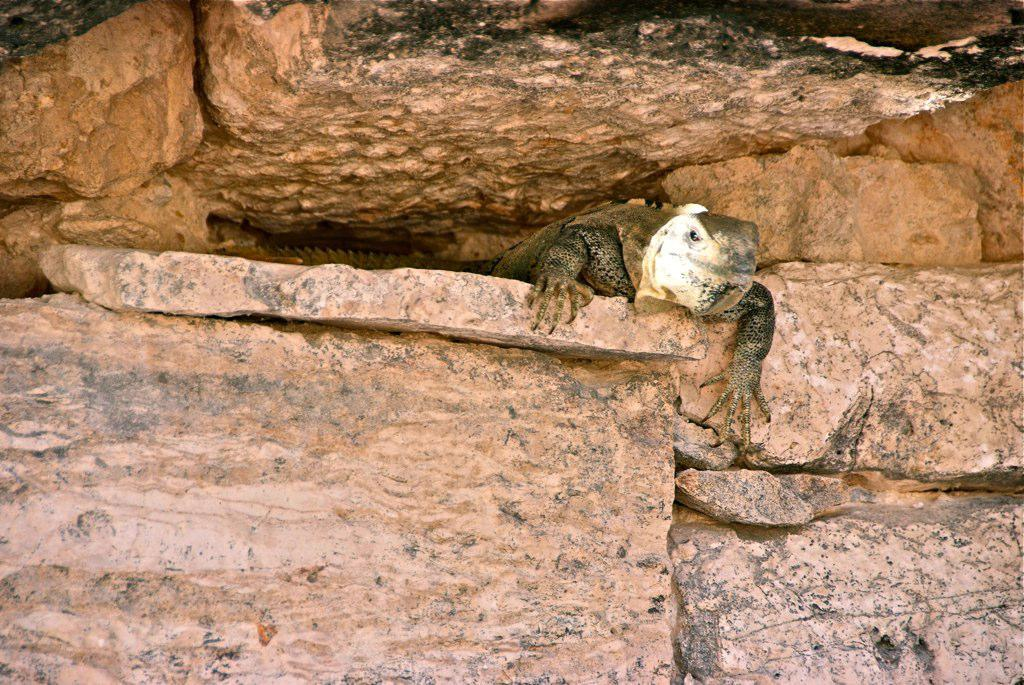What type of animal is in the image? There is a lizard-like reptile in the image. Where is the reptile located? The reptile is in a rock cave. What type of sweater is the parent wearing in the image? There is no parent or sweater present in the image; it features a lizard-like reptile in a rock cave. 